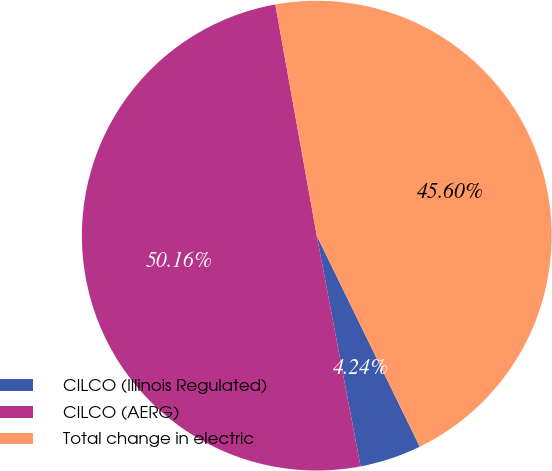<chart> <loc_0><loc_0><loc_500><loc_500><pie_chart><fcel>CILCO (Illinois Regulated)<fcel>CILCO (AERG)<fcel>Total change in electric<nl><fcel>4.24%<fcel>50.16%<fcel>45.6%<nl></chart> 